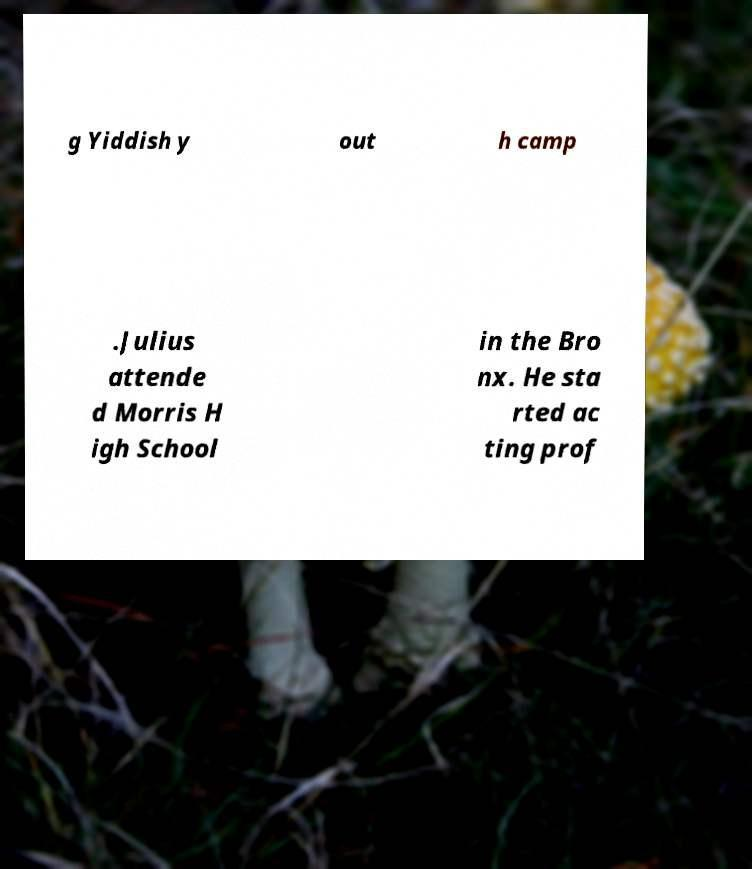Please read and relay the text visible in this image. What does it say? g Yiddish y out h camp .Julius attende d Morris H igh School in the Bro nx. He sta rted ac ting prof 